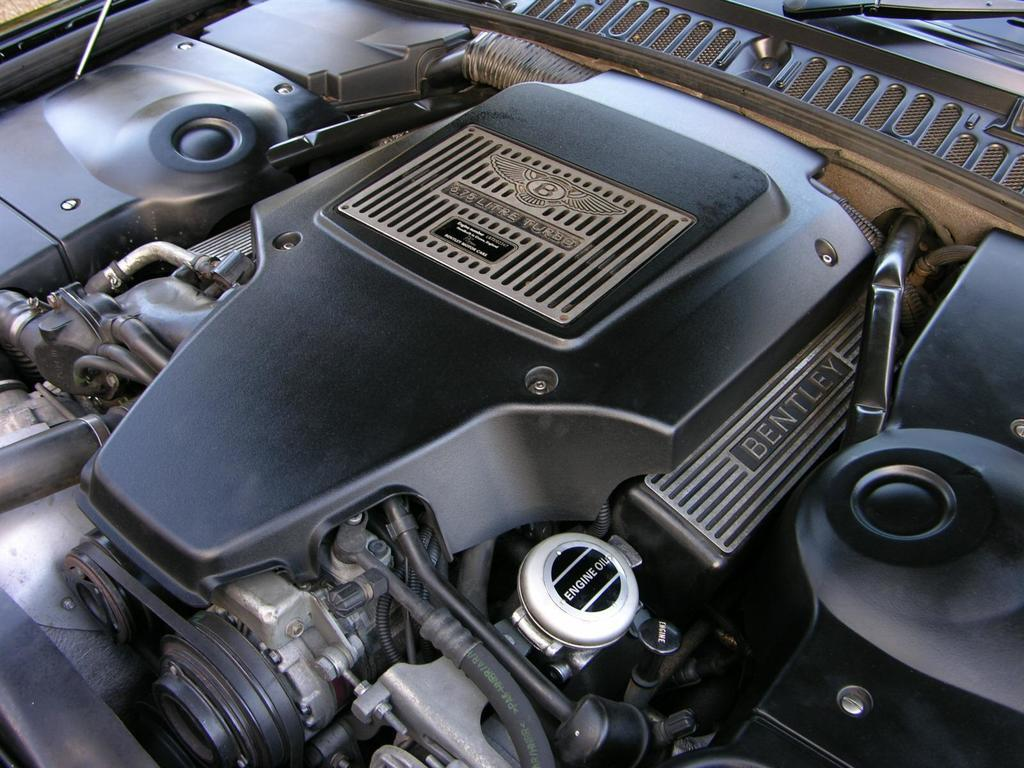What is the main subject of the image? The main subject of the image is the engine of a car. Are there any other parts of the car visible in the image? Yes, some parts of the car are visible in the image. What type of wound can be seen on the seat in the image? There is no seat or wound present in the image; it only contains the engine of a car. 